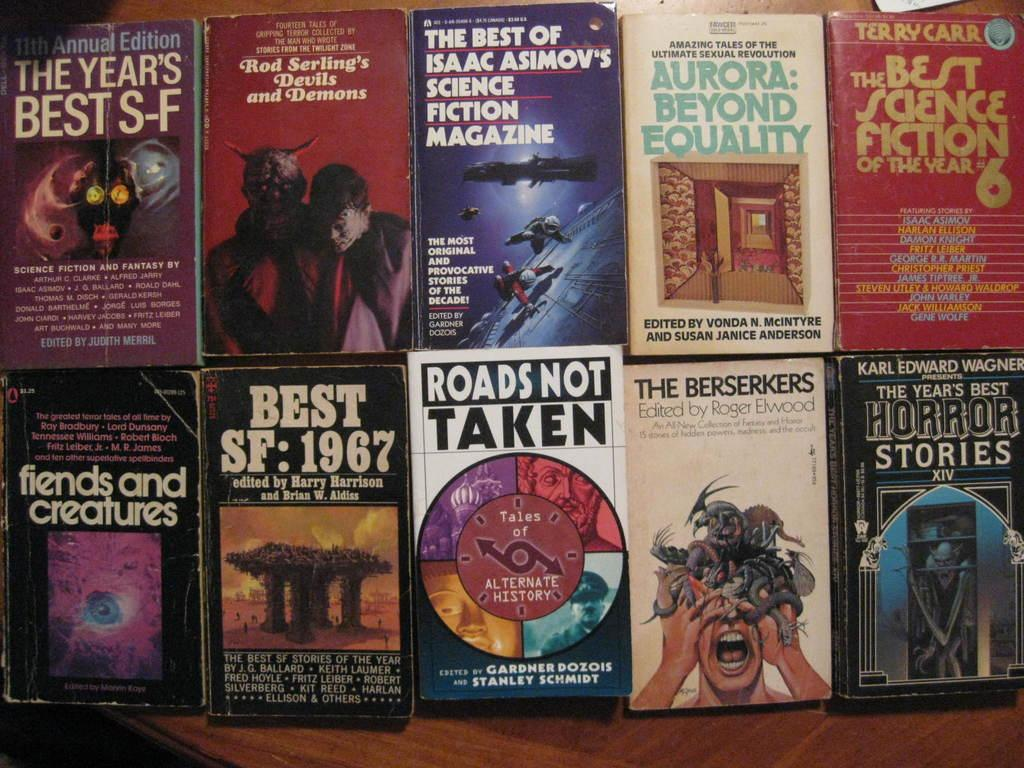<image>
Render a clear and concise summary of the photo. A group of books includes on titled Roads Not Taken. 